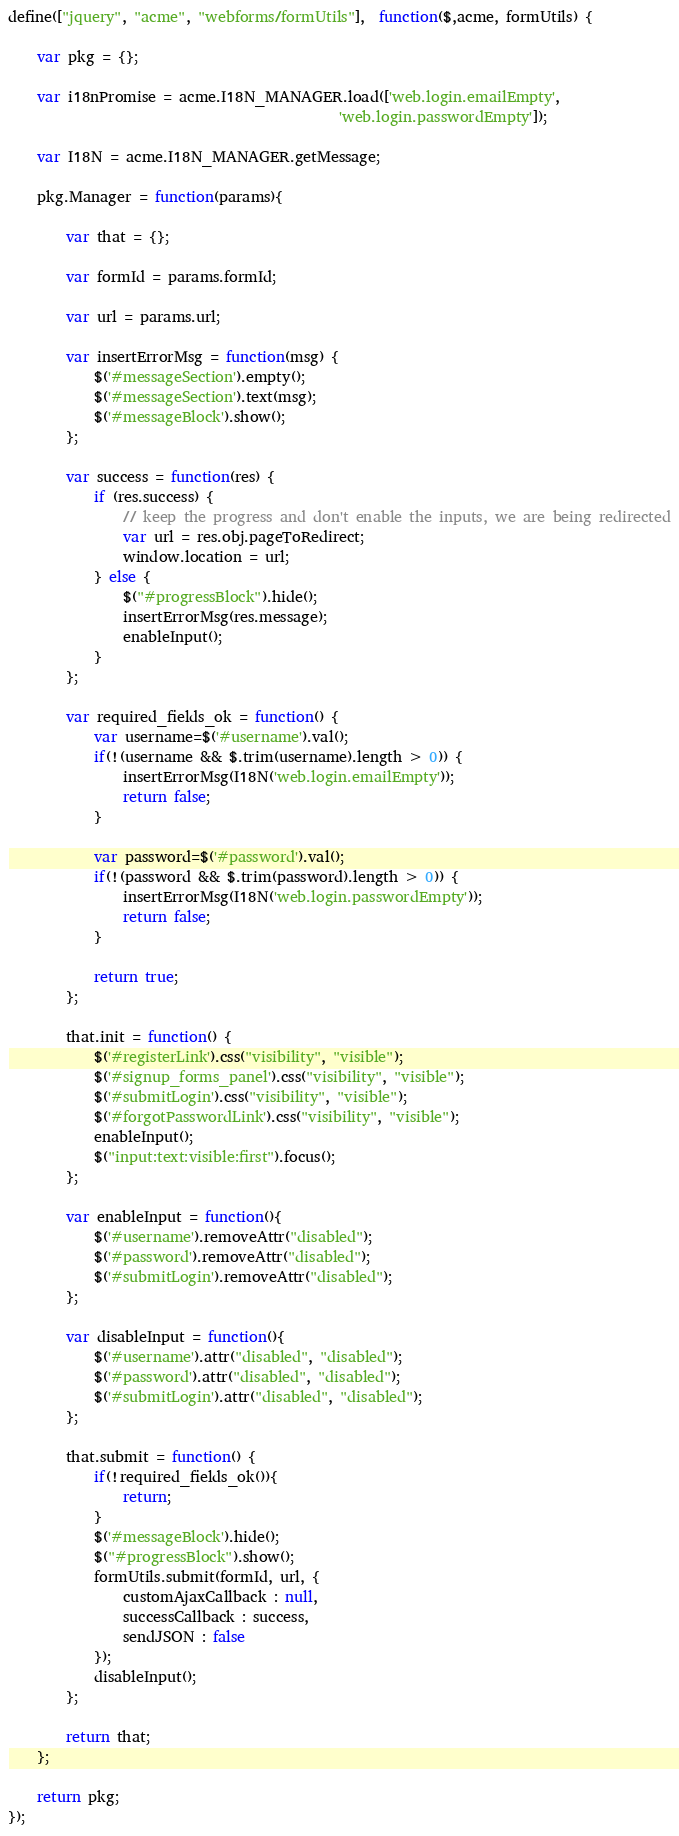<code> <loc_0><loc_0><loc_500><loc_500><_JavaScript_>define(["jquery", "acme", "webforms/formUtils"],  function($,acme, formUtils) {
	
	var pkg = {};
	
	var i18nPromise = acme.I18N_MANAGER.load(['web.login.emailEmpty',
	                                          'web.login.passwordEmpty']);
	
	var I18N = acme.I18N_MANAGER.getMessage;
	
	pkg.Manager = function(params){
		
		var that = {};
		
		var formId = params.formId;
		
		var url = params.url;
		
		var insertErrorMsg = function(msg) {
			$('#messageSection').empty();
			$('#messageSection').text(msg);
			$('#messageBlock').show();
		};
	
		var success = function(res) {
			if (res.success) {
				// keep the progress and don't enable the inputs, we are being redirected
				var url = res.obj.pageToRedirect;
				window.location = url;
			} else {
				$("#progressBlock").hide();
				insertErrorMsg(res.message);
				enableInput();
			}
		};
		
		var required_fields_ok = function() {
			var username=$('#username').val();
			if(!(username && $.trim(username).length > 0)) {
				insertErrorMsg(I18N('web.login.emailEmpty'));
				return false;
			}
			
			var password=$('#password').val();
			if(!(password && $.trim(password).length > 0)) {
				insertErrorMsg(I18N('web.login.passwordEmpty'));
				return false;
			}
			
			return true;
		};
	
		that.init = function() {
			$('#registerLink').css("visibility", "visible");
			$('#signup_forms_panel').css("visibility", "visible");
			$('#submitLogin').css("visibility", "visible");
			$('#forgotPasswordLink').css("visibility", "visible");
			enableInput();
			$("input:text:visible:first").focus();
		};
		
		var enableInput = function(){
			$('#username').removeAttr("disabled");
			$('#password').removeAttr("disabled");
			$('#submitLogin').removeAttr("disabled");
		};
		
		var disableInput = function(){
			$('#username').attr("disabled", "disabled");
			$('#password').attr("disabled", "disabled");
			$('#submitLogin').attr("disabled", "disabled");
		};
		
		that.submit = function() {		
			if(!required_fields_ok()){
				return;
			}
			$('#messageBlock').hide();
			$("#progressBlock").show();
			formUtils.submit(formId, url, {
				customAjaxCallback : null,
				successCallback : success,
				sendJSON : false
			});
			disableInput();
		};
		
		return that;
	};
	
	return pkg;
});
</code> 